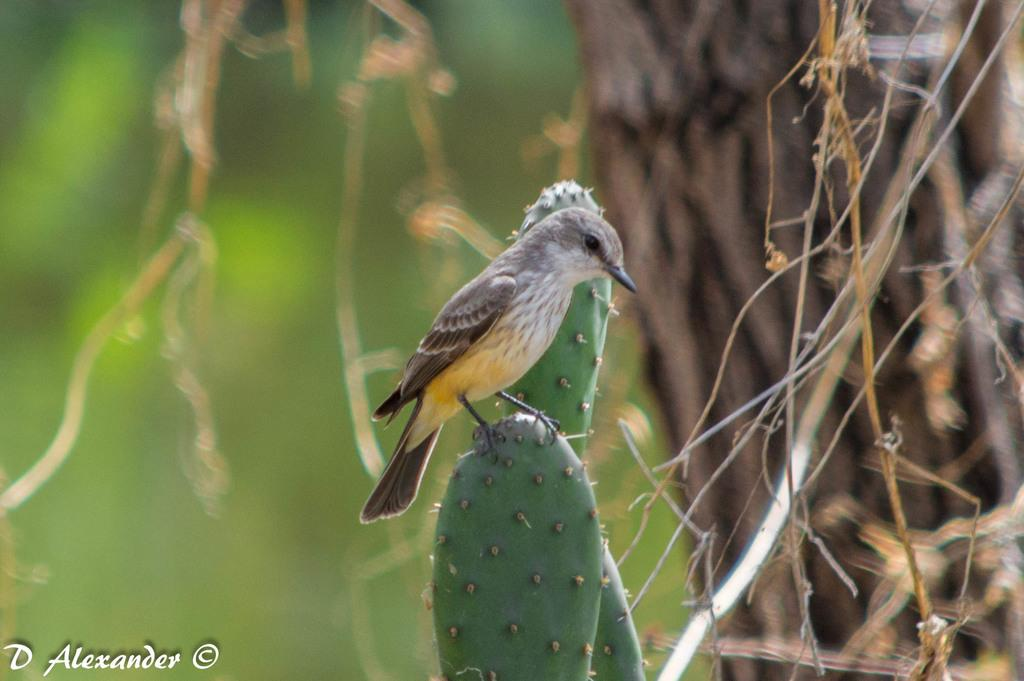What type of bird can be seen in the image? There is a small brown color bird in the image. Where is the bird located? The bird is sitting on a cactus plant. Can you describe the background of the image? The background is blurred, but it includes a tree trunk and dry leaves. What type of society is depicted in the image? There is no society depicted in the image; it features a small brown color bird sitting on a cactus plant. How many points can be seen in the image? There are no points visible in the image. 